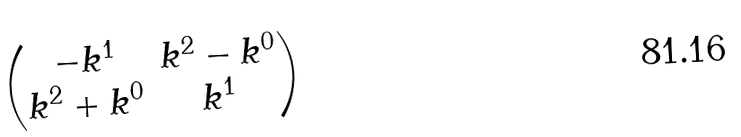Convert formula to latex. <formula><loc_0><loc_0><loc_500><loc_500>\begin{pmatrix} - k ^ { 1 } & k ^ { 2 } - k ^ { 0 } \\ k ^ { 2 } + k ^ { 0 } & k ^ { 1 } \\ \end{pmatrix}</formula> 